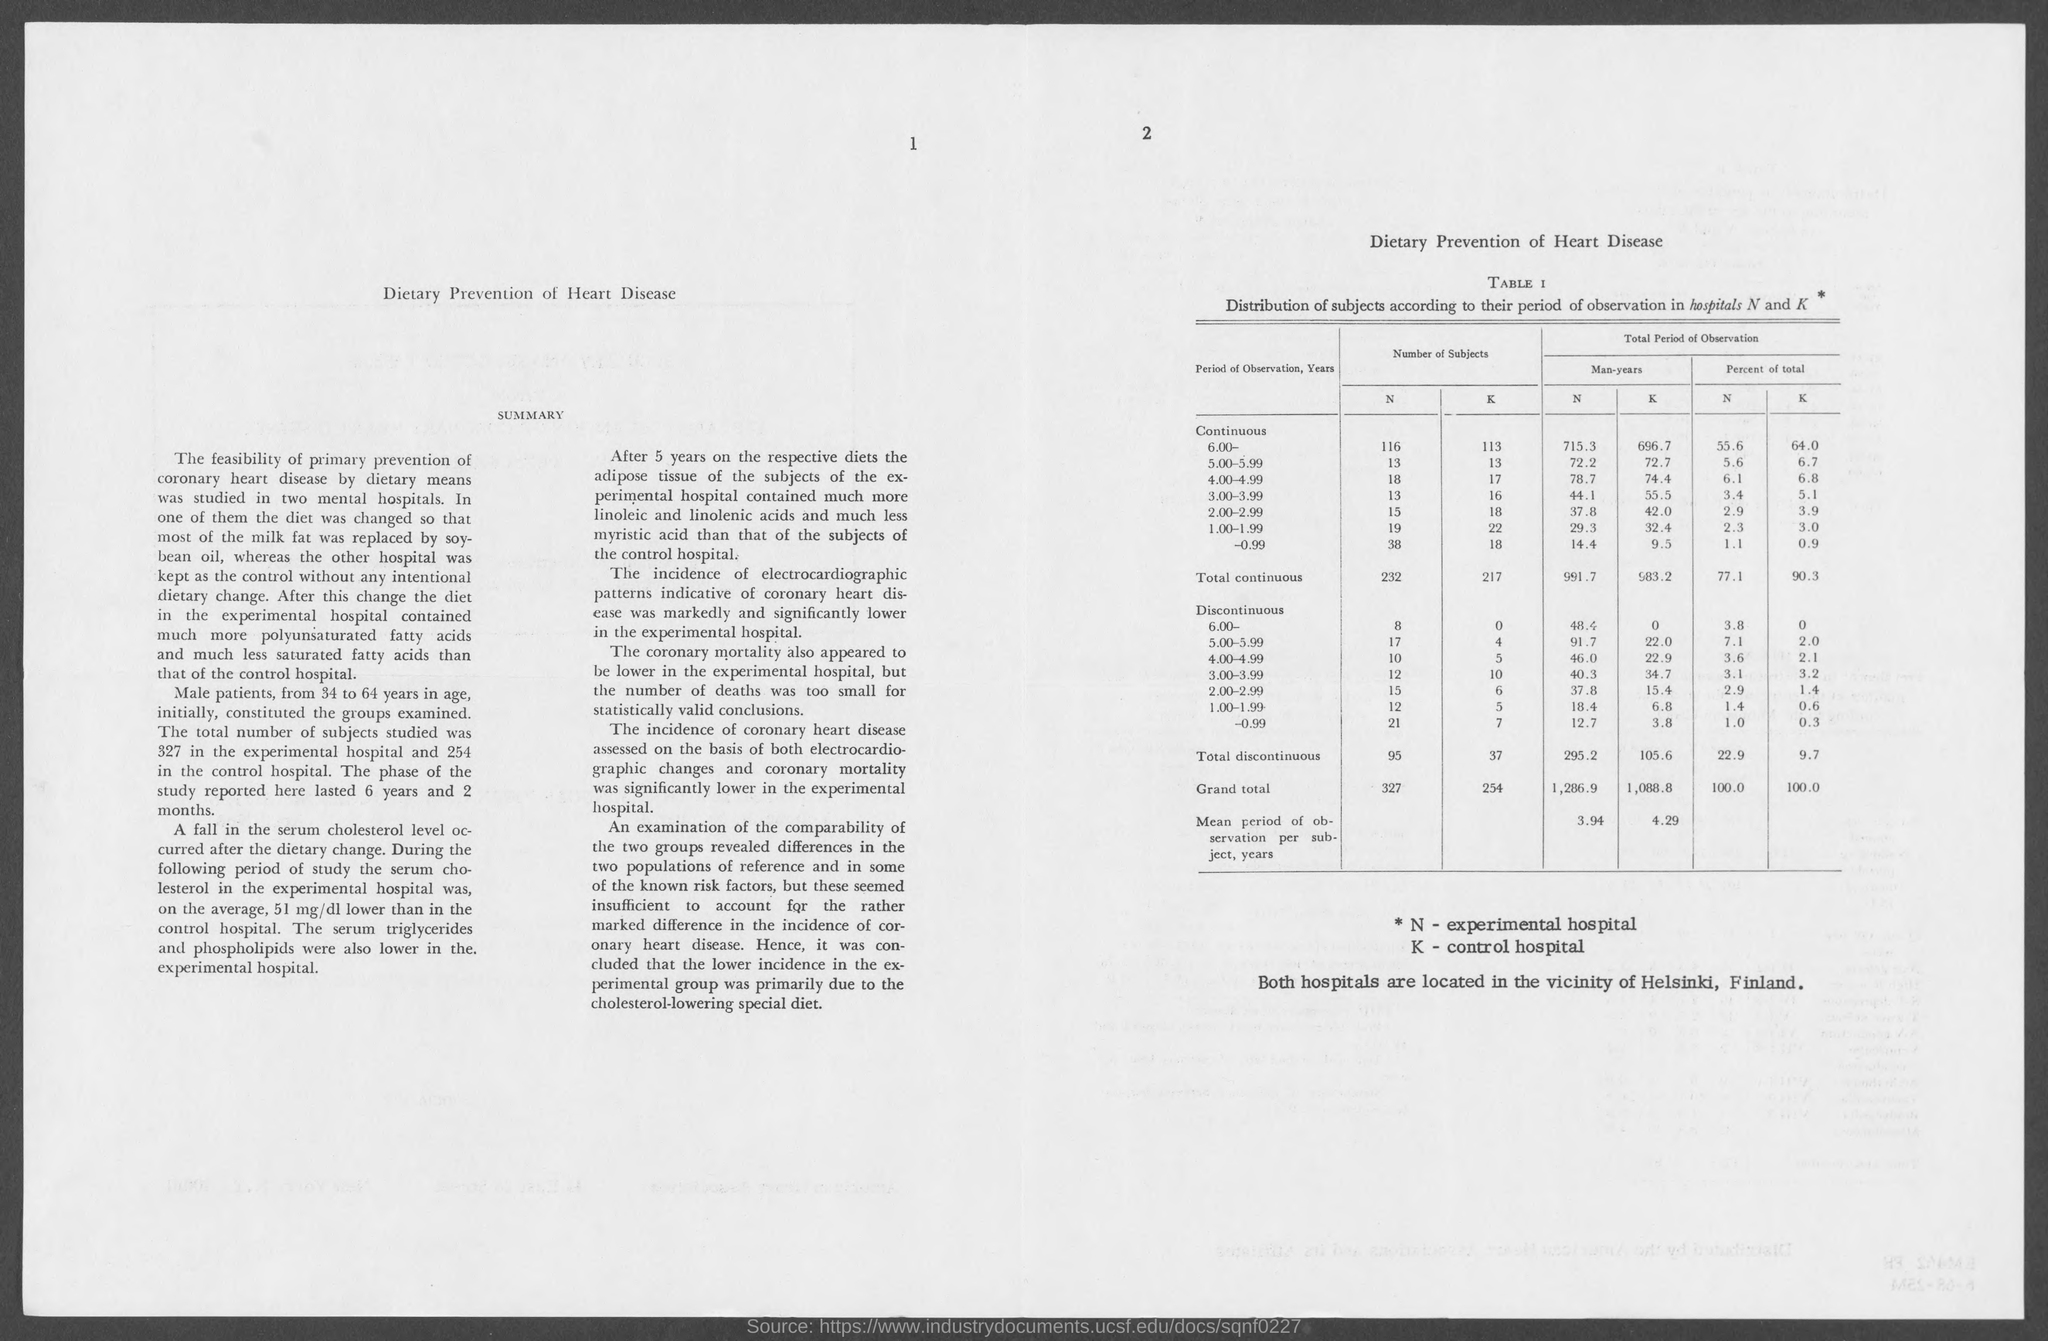What is the title of the document?
Give a very brief answer. Dietary Prevention of Heart Disease. What is the title of Table 1?
Offer a very short reply. Distribution of subjects according to their period of observation in hospitals N and k. What type of hospitals is represented by 'N' ?
Your answer should be compact. Experimental hospital. What type of hospitals is represented by 'K' ?
Keep it short and to the point. Control hospital. Where both hospitals are located?
Your response must be concise. Vicinity of helsinki, finland. 